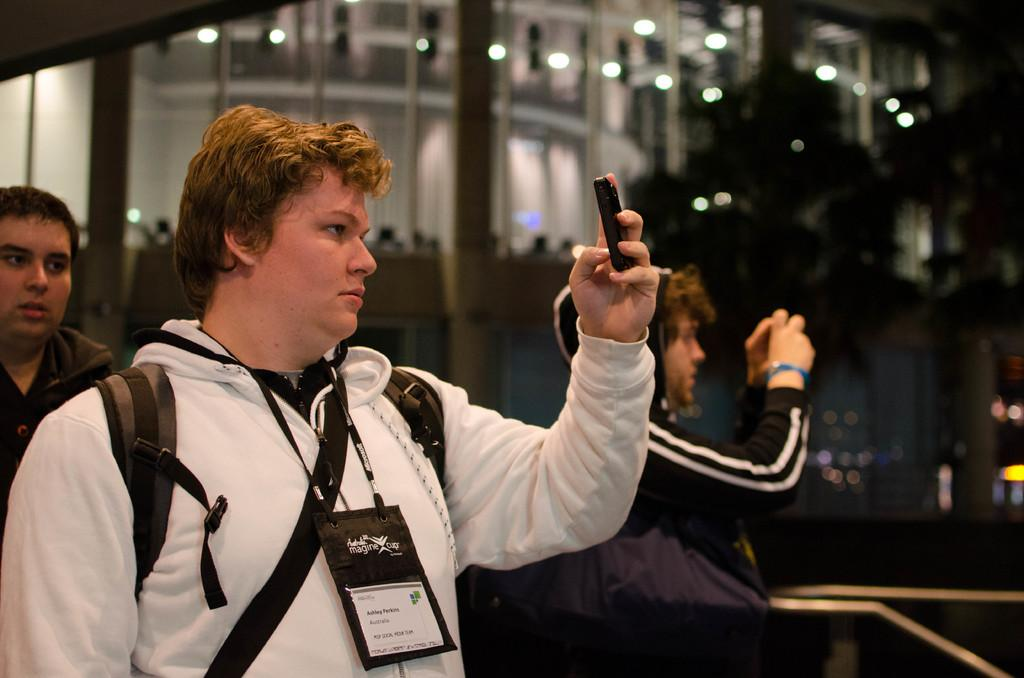Who is present in the image? There are people in the image. What are the people doing in the image? The people are standing and taking pictures using their mobiles. What is the afterthought of the people in the image? There is no indication of an afterthought in the image, as the people are actively taking pictures using their mobiles. 